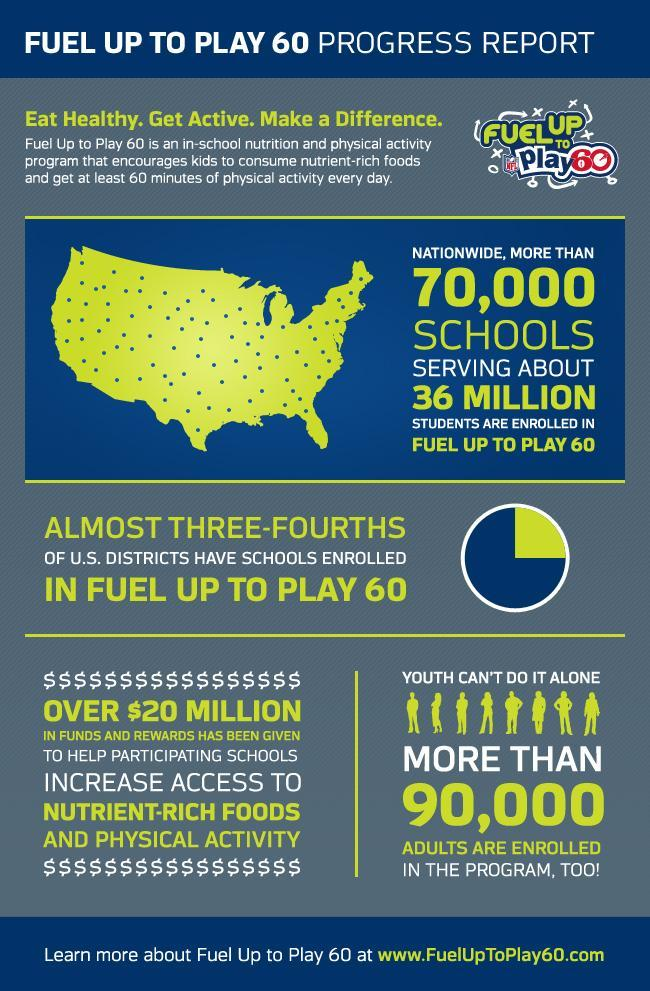What percentage of schools in United States have not enrolled "Fuel Up To Play 60"?
Answer the question with a short phrase. 0.25 How many Grown-ups have joined the "Fuel Up To Play 60" program? more than 90,000 